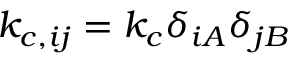Convert formula to latex. <formula><loc_0><loc_0><loc_500><loc_500>k _ { c , i j } = k _ { c } \delta _ { i A } \delta _ { j B }</formula> 